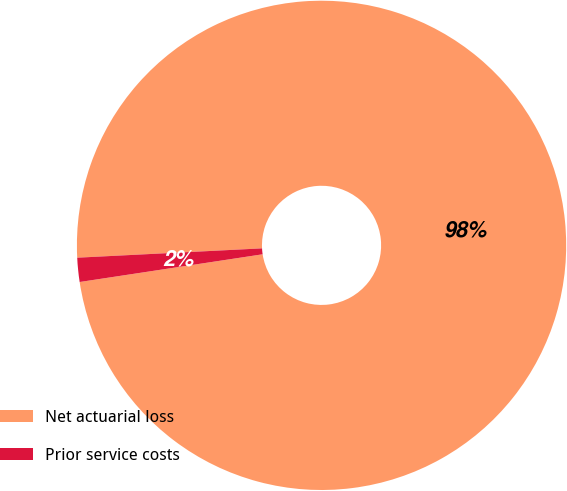Convert chart. <chart><loc_0><loc_0><loc_500><loc_500><pie_chart><fcel>Net actuarial loss<fcel>Prior service costs<nl><fcel>98.41%<fcel>1.59%<nl></chart> 